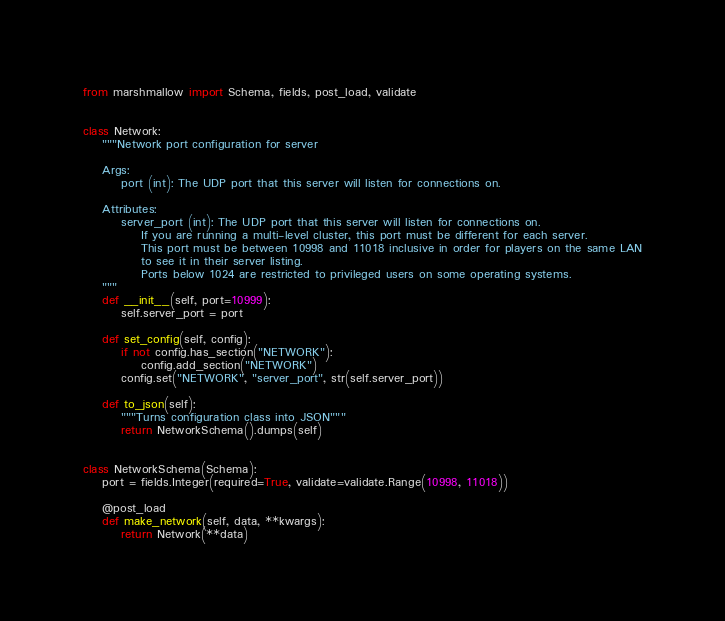Convert code to text. <code><loc_0><loc_0><loc_500><loc_500><_Python_>from marshmallow import Schema, fields, post_load, validate


class Network:
    """Network port configuration for server

    Args:
        port (int): The UDP port that this server will listen for connections on.

    Attributes:
        server_port (int): The UDP port that this server will listen for connections on.
            If you are running a multi-level cluster, this port must be different for each server.
            This port must be between 10998 and 11018 inclusive in order for players on the same LAN
            to see it in their server listing.
            Ports below 1024 are restricted to privileged users on some operating systems.
    """
    def __init__(self, port=10999):
        self.server_port = port

    def set_config(self, config):
        if not config.has_section("NETWORK"):
            config.add_section("NETWORK")
        config.set("NETWORK", "server_port", str(self.server_port))

    def to_json(self):
        """Turns configuration class into JSON"""
        return NetworkSchema().dumps(self)


class NetworkSchema(Schema):
    port = fields.Integer(required=True, validate=validate.Range(10998, 11018))

    @post_load
    def make_network(self, data, **kwargs):
        return Network(**data)


</code> 